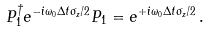<formula> <loc_0><loc_0><loc_500><loc_500>P _ { 1 } ^ { \dagger } e ^ { - i \omega _ { 0 } \Delta t \sigma _ { z } / 2 } P _ { 1 } = e ^ { + i \omega _ { 0 } \Delta t \sigma _ { z } / 2 } \, .</formula> 